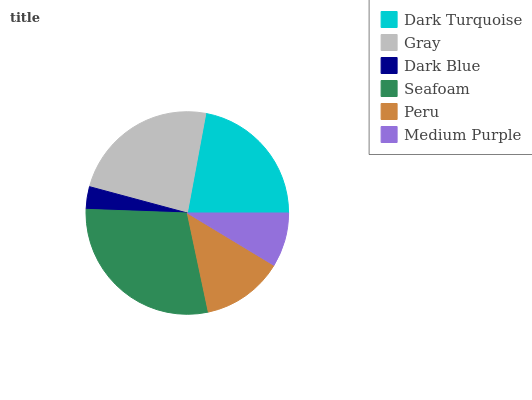Is Dark Blue the minimum?
Answer yes or no. Yes. Is Seafoam the maximum?
Answer yes or no. Yes. Is Gray the minimum?
Answer yes or no. No. Is Gray the maximum?
Answer yes or no. No. Is Gray greater than Dark Turquoise?
Answer yes or no. Yes. Is Dark Turquoise less than Gray?
Answer yes or no. Yes. Is Dark Turquoise greater than Gray?
Answer yes or no. No. Is Gray less than Dark Turquoise?
Answer yes or no. No. Is Dark Turquoise the high median?
Answer yes or no. Yes. Is Peru the low median?
Answer yes or no. Yes. Is Gray the high median?
Answer yes or no. No. Is Dark Blue the low median?
Answer yes or no. No. 